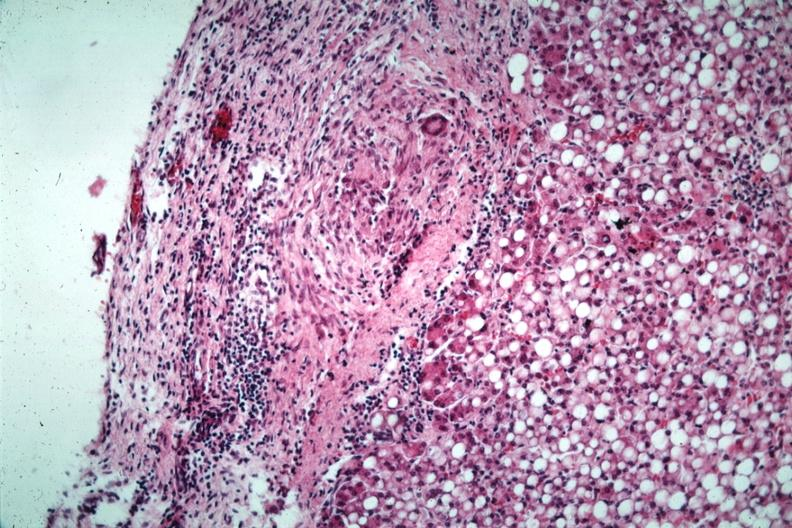does this image show liver with tuberculoid granuloma in glissons capsule quite good liver has marked fatty change?
Answer the question using a single word or phrase. Yes 